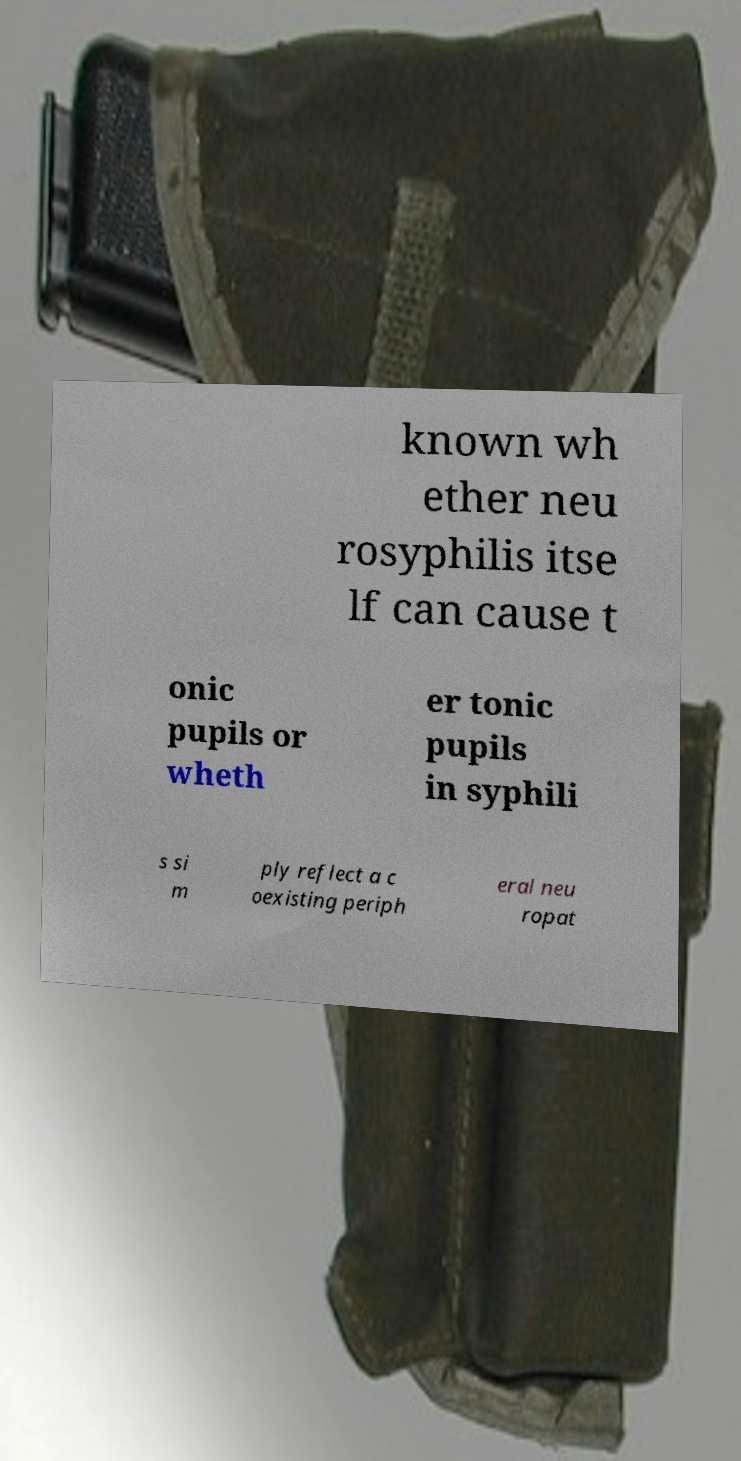For documentation purposes, I need the text within this image transcribed. Could you provide that? known wh ether neu rosyphilis itse lf can cause t onic pupils or wheth er tonic pupils in syphili s si m ply reflect a c oexisting periph eral neu ropat 